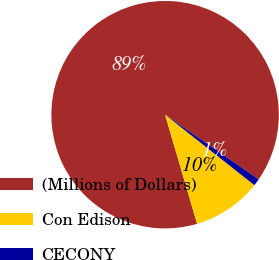<chart> <loc_0><loc_0><loc_500><loc_500><pie_chart><fcel>(Millions of Dollars)<fcel>Con Edison<fcel>CECONY<nl><fcel>89.15%<fcel>9.83%<fcel>1.02%<nl></chart> 